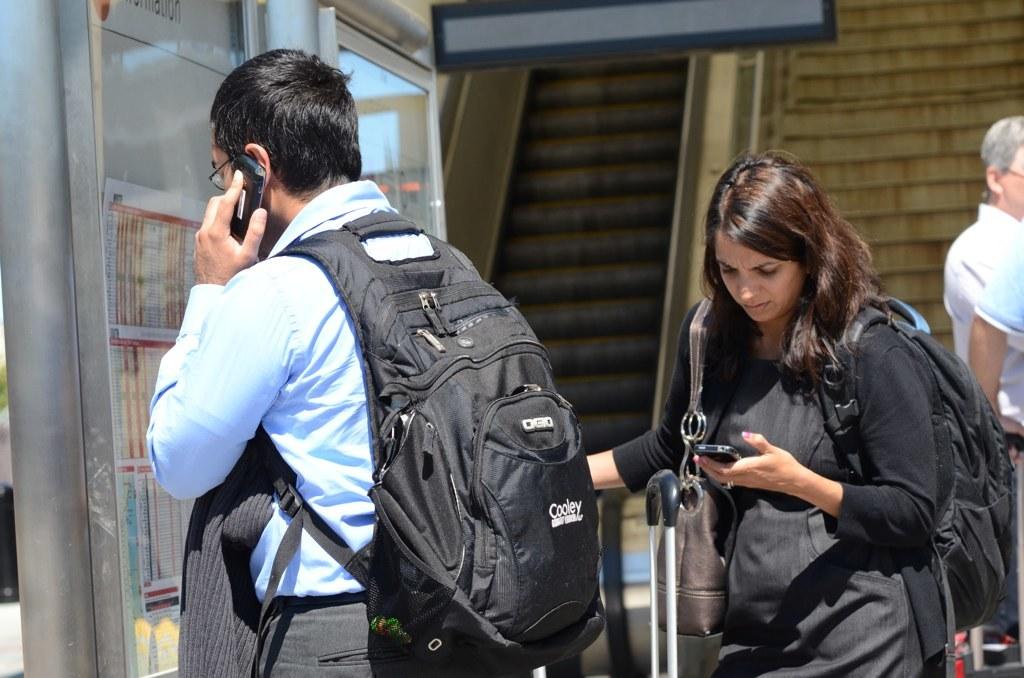What brand of backpack is the man wearing?
Your response must be concise. Cooley. 